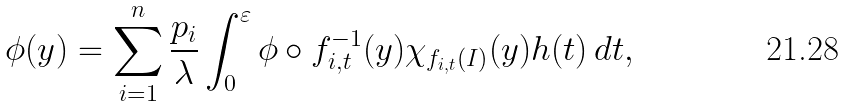<formula> <loc_0><loc_0><loc_500><loc_500>\L \phi ( y ) = \sum _ { i = 1 } ^ { n } \frac { p _ { i } } { \lambda } \int _ { 0 } ^ { \varepsilon } \phi \circ f _ { i , t } ^ { - 1 } ( y ) \chi _ { f _ { i , t } ( I ) } ( y ) h ( t ) \, d t ,</formula> 